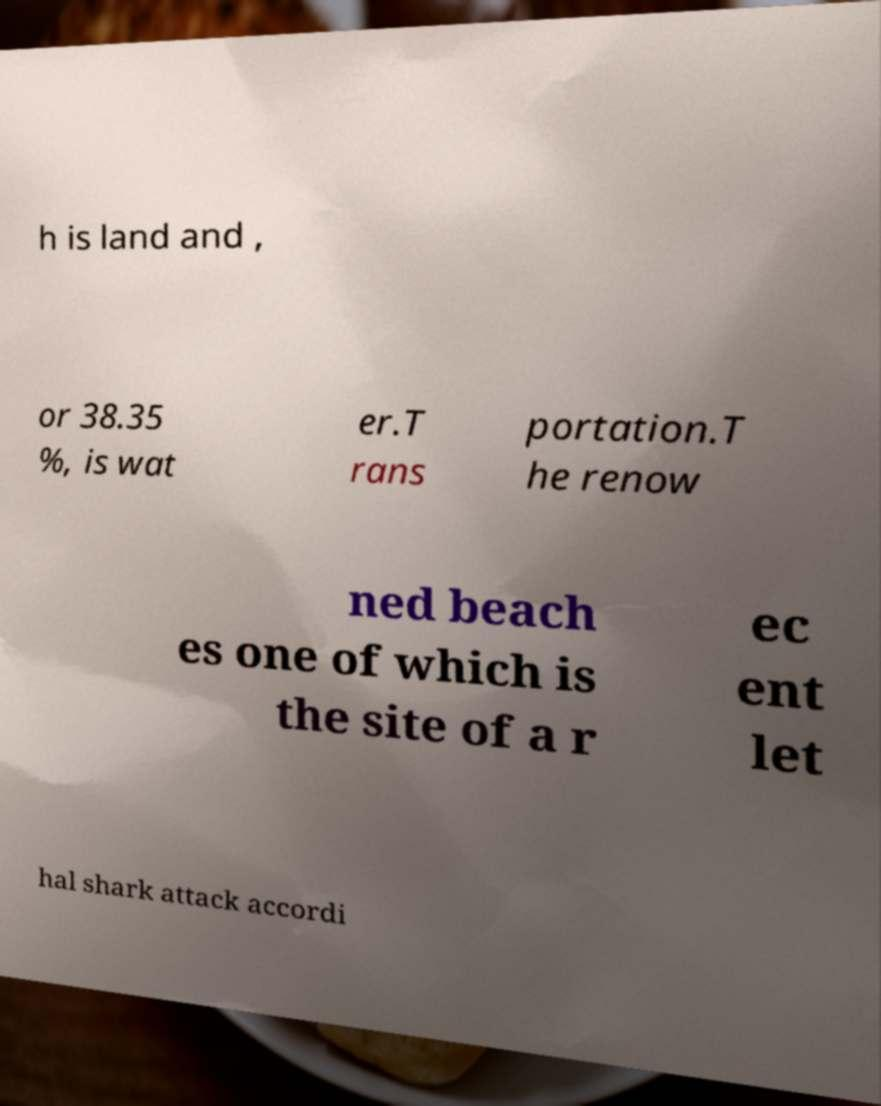There's text embedded in this image that I need extracted. Can you transcribe it verbatim? h is land and , or 38.35 %, is wat er.T rans portation.T he renow ned beach es one of which is the site of a r ec ent let hal shark attack accordi 